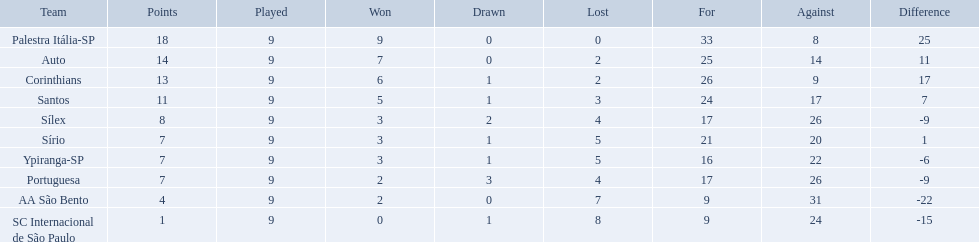What were all the teams that competed in 1926 brazilian football? Palestra Itália-SP, Auto, Corinthians, Santos, Sílex, Sírio, Ypiranga-SP, Portuguesa, AA São Bento, SC Internacional de São Paulo. Which of these had zero games lost? Palestra Itália-SP. Which teams were playing brazilian football in 1926? Palestra Itália-SP, Auto, Corinthians, Santos, Sílex, Sírio, Ypiranga-SP, Portuguesa, AA São Bento, SC Internacional de São Paulo. Of those teams, which one scored 13 points? Corinthians. What were the top three amounts of games won for 1926 in brazilian football season? 9, 7, 6. What were the top amount of games won for 1926 in brazilian football season? 9. What team won the top amount of games Palestra Itália-SP. 